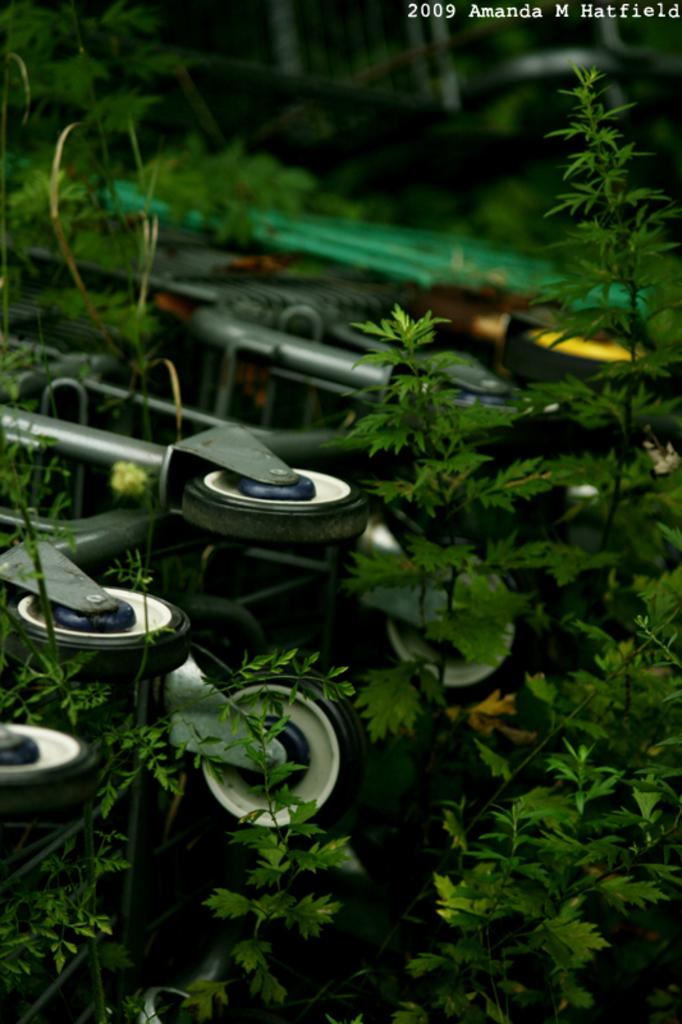What is present on the stand in the image? There are wheels on a stand in the image. What else can be seen in the image besides the stand? There are plants in the image. How would you describe the quality of the image? The image is slightly blurred. Is there any text present in the image? Yes, there is edited text in the image. Can you see a heart-shaped object in the image? There is no heart-shaped object present in the image. What type of feast is being prepared in the image? There is no feast or food preparation visible in the image. 